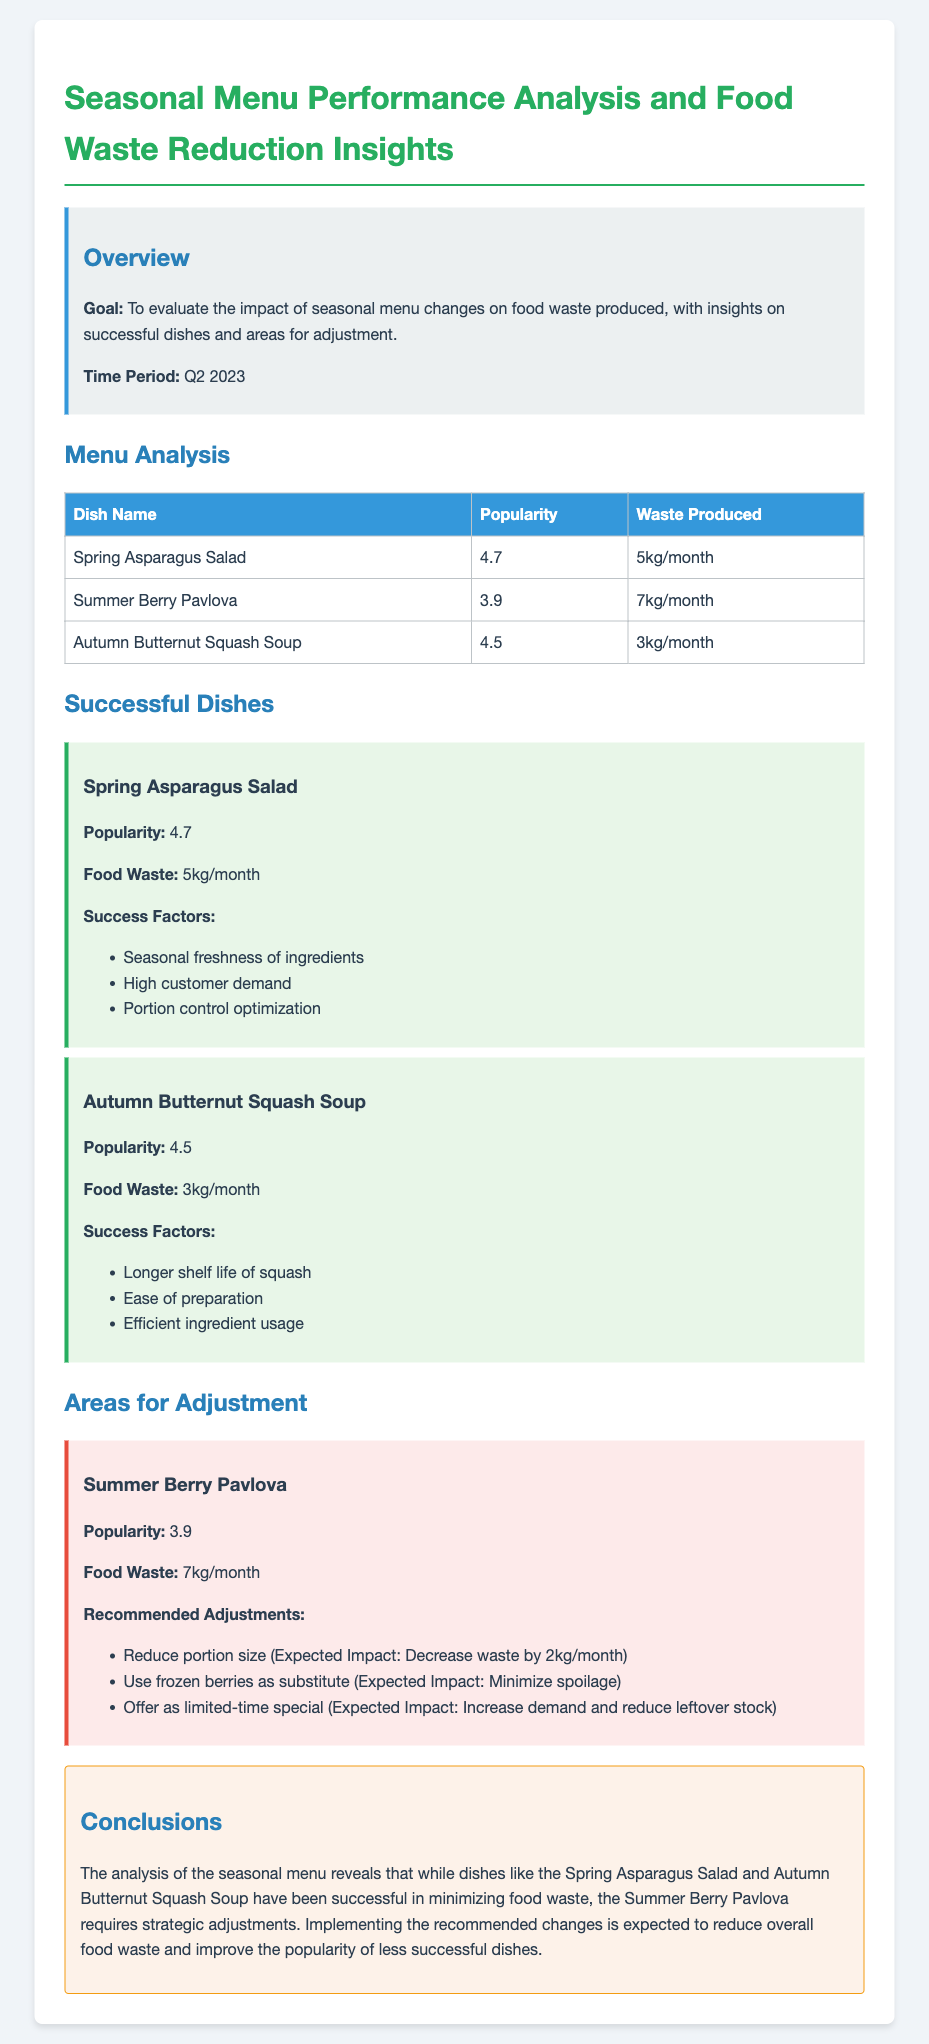What is the goal of the analysis? The goal is to evaluate the impact of seasonal menu changes on food waste produced, with insights on successful dishes and areas for adjustment.
Answer: Evaluate the impact of seasonal menu changes on food waste produced What dish produced the least food waste? The dish with the least food waste is Autumn Butternut Squash Soup, which produced 3kg/month.
Answer: Autumn Butternut Squash Soup What is the popularity rating of the Spring Asparagus Salad? The popularity rating of the Spring Asparagus Salad is 4.7.
Answer: 4.7 What are the recommended adjustments for the Summer Berry Pavlova? The recommendations include reducing portion size, using frozen berries, and offering it as a limited-time special.
Answer: Reduce portion size, use frozen berries, offer as limited-time special What was the food waste produced by the Summer Berry Pavlova? The Summer Berry Pavlova produced 7kg/month of food waste.
Answer: 7kg/month 